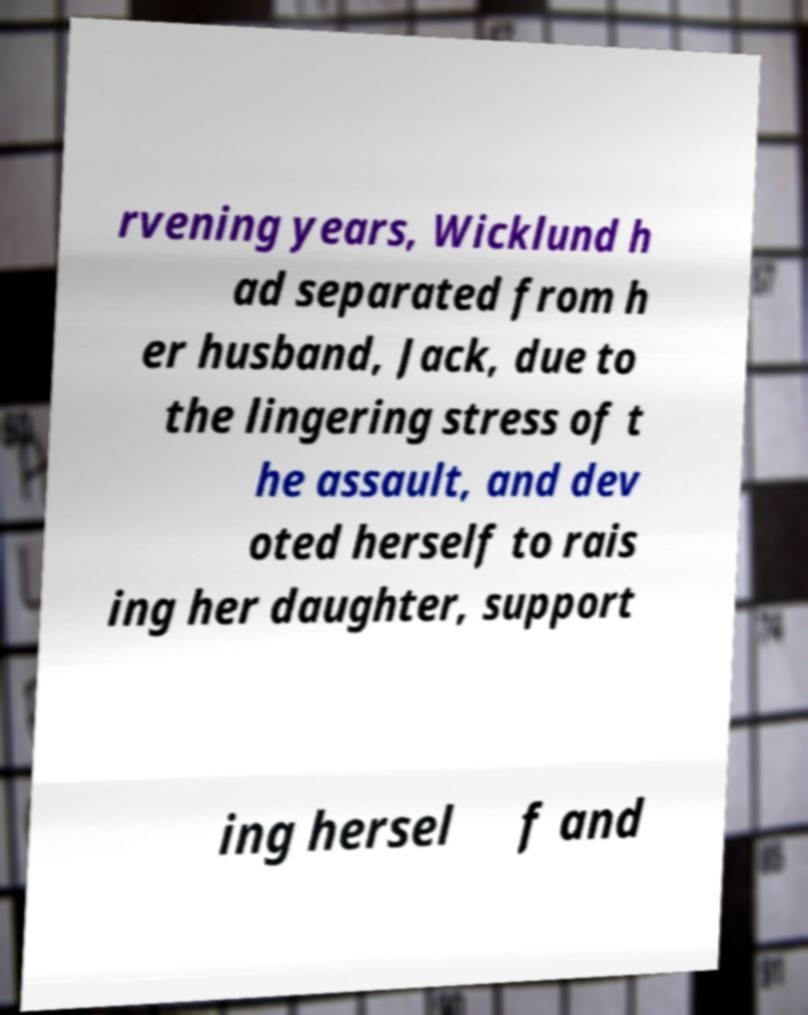Please identify and transcribe the text found in this image. rvening years, Wicklund h ad separated from h er husband, Jack, due to the lingering stress of t he assault, and dev oted herself to rais ing her daughter, support ing hersel f and 